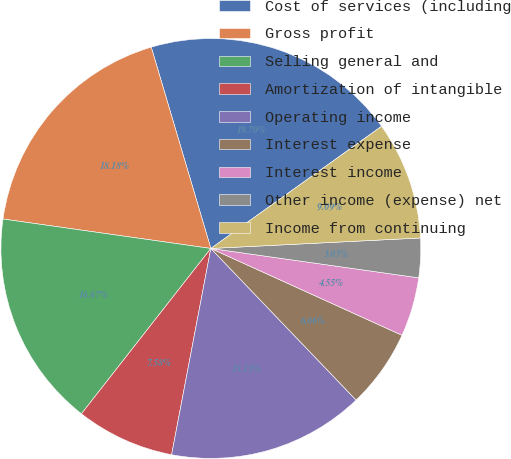Convert chart. <chart><loc_0><loc_0><loc_500><loc_500><pie_chart><fcel>Cost of services (including<fcel>Gross profit<fcel>Selling general and<fcel>Amortization of intangible<fcel>Operating income<fcel>Interest expense<fcel>Interest income<fcel>Other income (expense) net<fcel>Income from continuing<nl><fcel>19.7%<fcel>18.18%<fcel>16.67%<fcel>7.58%<fcel>15.15%<fcel>6.06%<fcel>4.55%<fcel>3.03%<fcel>9.09%<nl></chart> 